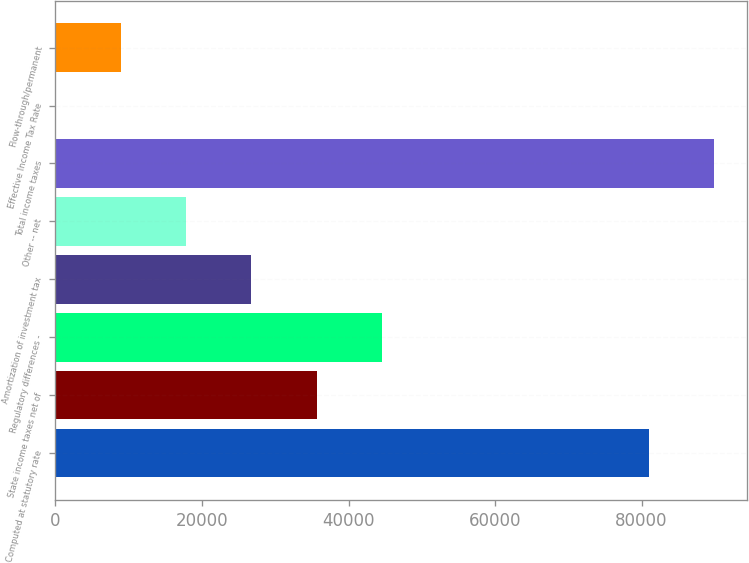<chart> <loc_0><loc_0><loc_500><loc_500><bar_chart><fcel>Computed at statutory rate<fcel>State income taxes net of<fcel>Regulatory differences -<fcel>Amortization of investment tax<fcel>Other -- net<fcel>Total income taxes<fcel>Effective Income Tax Rate<fcel>Flow-through/permanent<nl><fcel>80946<fcel>35648.7<fcel>44551.2<fcel>26746.2<fcel>17843.6<fcel>89848.6<fcel>38.5<fcel>8941.05<nl></chart> 